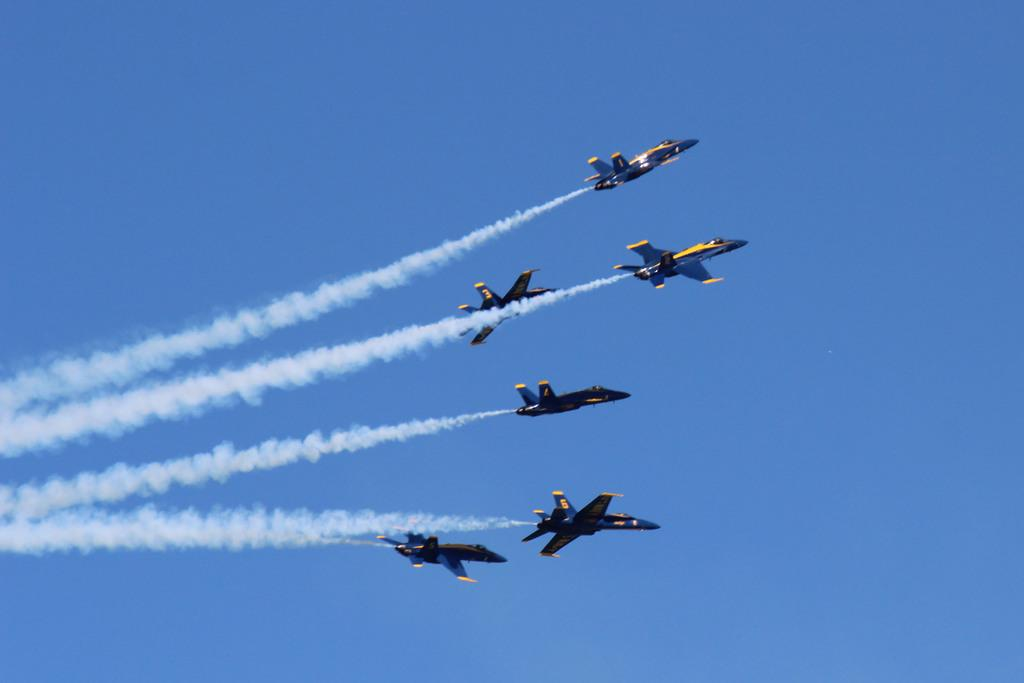How many jets can be seen in the image? There are six jets in the image. What are the jets doing in the image? The jets are flying in the sky. What can be observed behind the jets as they fly? The jets are leaving smoke trails in the image. Can you see the hands of the tiger in the image? There is no tiger present in the image, so its hands cannot be seen. 